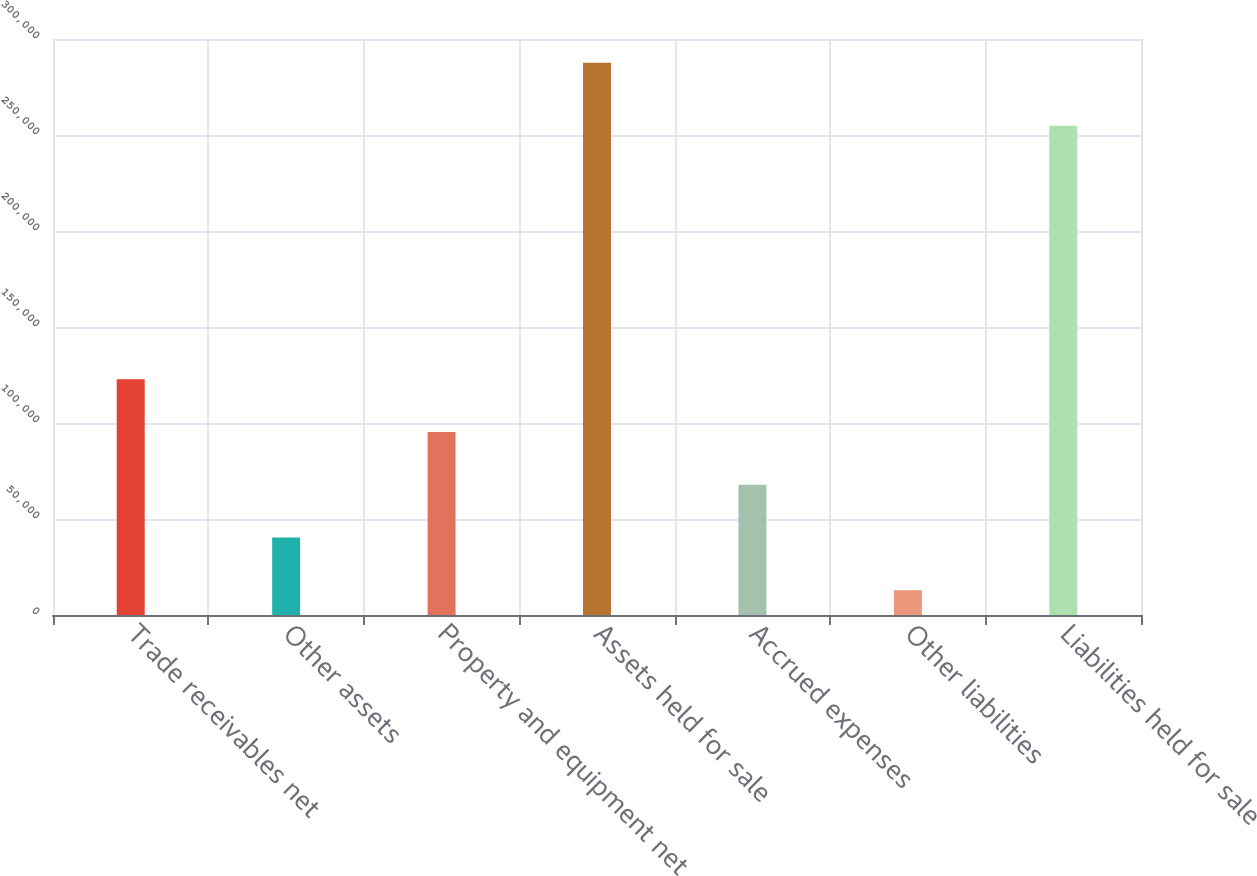Convert chart. <chart><loc_0><loc_0><loc_500><loc_500><bar_chart><fcel>Trade receivables net<fcel>Other assets<fcel>Property and equipment net<fcel>Assets held for sale<fcel>Accrued expenses<fcel>Other liabilities<fcel>Liabilities held for sale<nl><fcel>122796<fcel>40389<fcel>95327<fcel>287610<fcel>67858<fcel>12920<fcel>254760<nl></chart> 